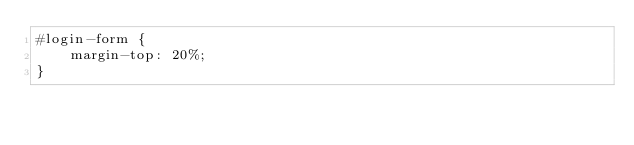Convert code to text. <code><loc_0><loc_0><loc_500><loc_500><_CSS_>#login-form {
    margin-top: 20%;
} </code> 